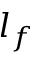<formula> <loc_0><loc_0><loc_500><loc_500>l _ { f }</formula> 